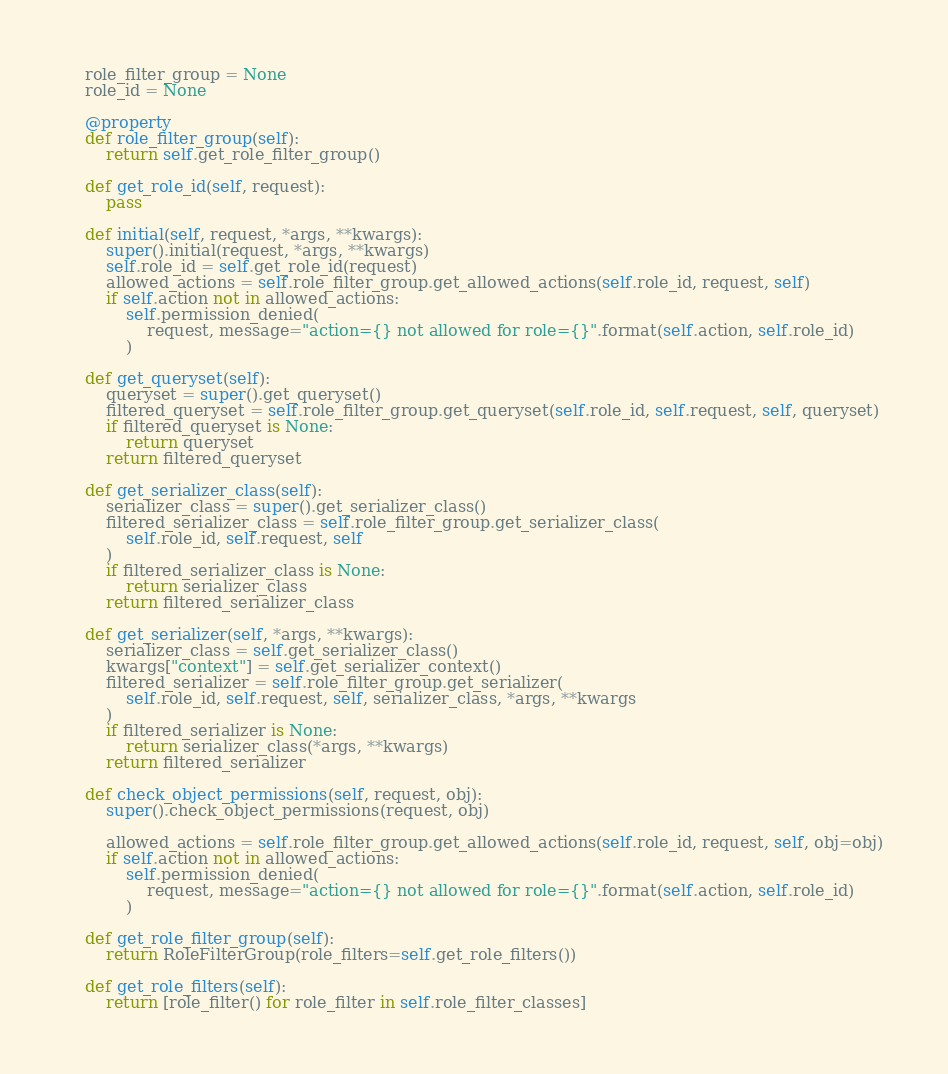Convert code to text. <code><loc_0><loc_0><loc_500><loc_500><_Python_>    role_filter_group = None
    role_id = None

    @property
    def role_filter_group(self):
        return self.get_role_filter_group()

    def get_role_id(self, request):
        pass

    def initial(self, request, *args, **kwargs):
        super().initial(request, *args, **kwargs)
        self.role_id = self.get_role_id(request)
        allowed_actions = self.role_filter_group.get_allowed_actions(self.role_id, request, self)
        if self.action not in allowed_actions:
            self.permission_denied(
                request, message="action={} not allowed for role={}".format(self.action, self.role_id)
            )

    def get_queryset(self):
        queryset = super().get_queryset()
        filtered_queryset = self.role_filter_group.get_queryset(self.role_id, self.request, self, queryset)
        if filtered_queryset is None:
            return queryset
        return filtered_queryset

    def get_serializer_class(self):
        serializer_class = super().get_serializer_class()
        filtered_serializer_class = self.role_filter_group.get_serializer_class(
            self.role_id, self.request, self
        )
        if filtered_serializer_class is None:
            return serializer_class
        return filtered_serializer_class

    def get_serializer(self, *args, **kwargs):
        serializer_class = self.get_serializer_class()
        kwargs["context"] = self.get_serializer_context()
        filtered_serializer = self.role_filter_group.get_serializer(
            self.role_id, self.request, self, serializer_class, *args, **kwargs
        )
        if filtered_serializer is None:
            return serializer_class(*args, **kwargs)
        return filtered_serializer

    def check_object_permissions(self, request, obj):
        super().check_object_permissions(request, obj)

        allowed_actions = self.role_filter_group.get_allowed_actions(self.role_id, request, self, obj=obj)
        if self.action not in allowed_actions:
            self.permission_denied(
                request, message="action={} not allowed for role={}".format(self.action, self.role_id)
            )

    def get_role_filter_group(self):
        return RoleFilterGroup(role_filters=self.get_role_filters())

    def get_role_filters(self):
        return [role_filter() for role_filter in self.role_filter_classes]
</code> 